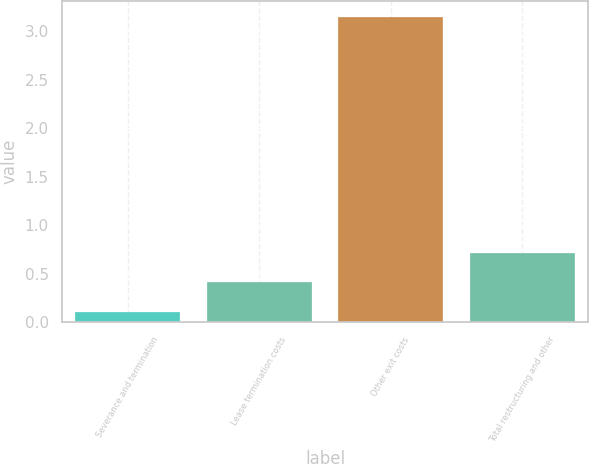Convert chart to OTSL. <chart><loc_0><loc_0><loc_500><loc_500><bar_chart><fcel>Severance and termination<fcel>Lease termination costs<fcel>Other exit costs<fcel>Total restructuring and other<nl><fcel>0.1<fcel>0.41<fcel>3.15<fcel>0.71<nl></chart> 